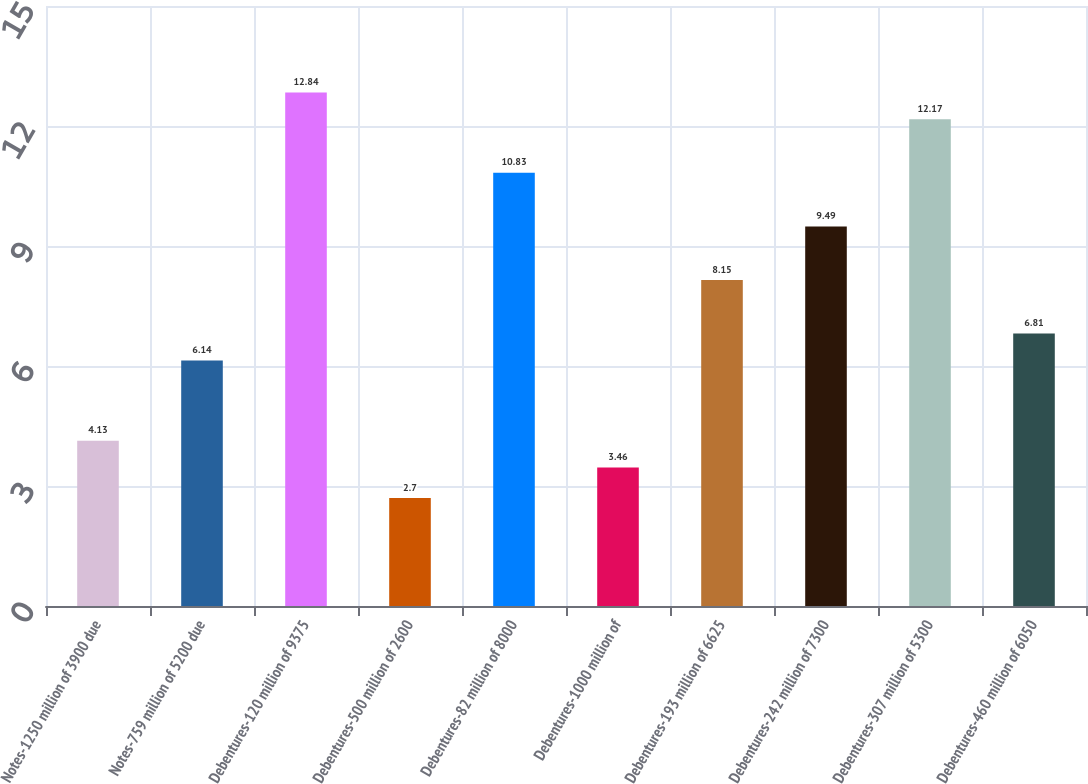Convert chart to OTSL. <chart><loc_0><loc_0><loc_500><loc_500><bar_chart><fcel>Notes-1250 million of 3900 due<fcel>Notes-759 million of 5200 due<fcel>Debentures-120 million of 9375<fcel>Debentures-500 million of 2600<fcel>Debentures-82 million of 8000<fcel>Debentures-1000 million of<fcel>Debentures-193 million of 6625<fcel>Debentures-242 million of 7300<fcel>Debentures-307 million of 5300<fcel>Debentures-460 million of 6050<nl><fcel>4.13<fcel>6.14<fcel>12.84<fcel>2.7<fcel>10.83<fcel>3.46<fcel>8.15<fcel>9.49<fcel>12.17<fcel>6.81<nl></chart> 